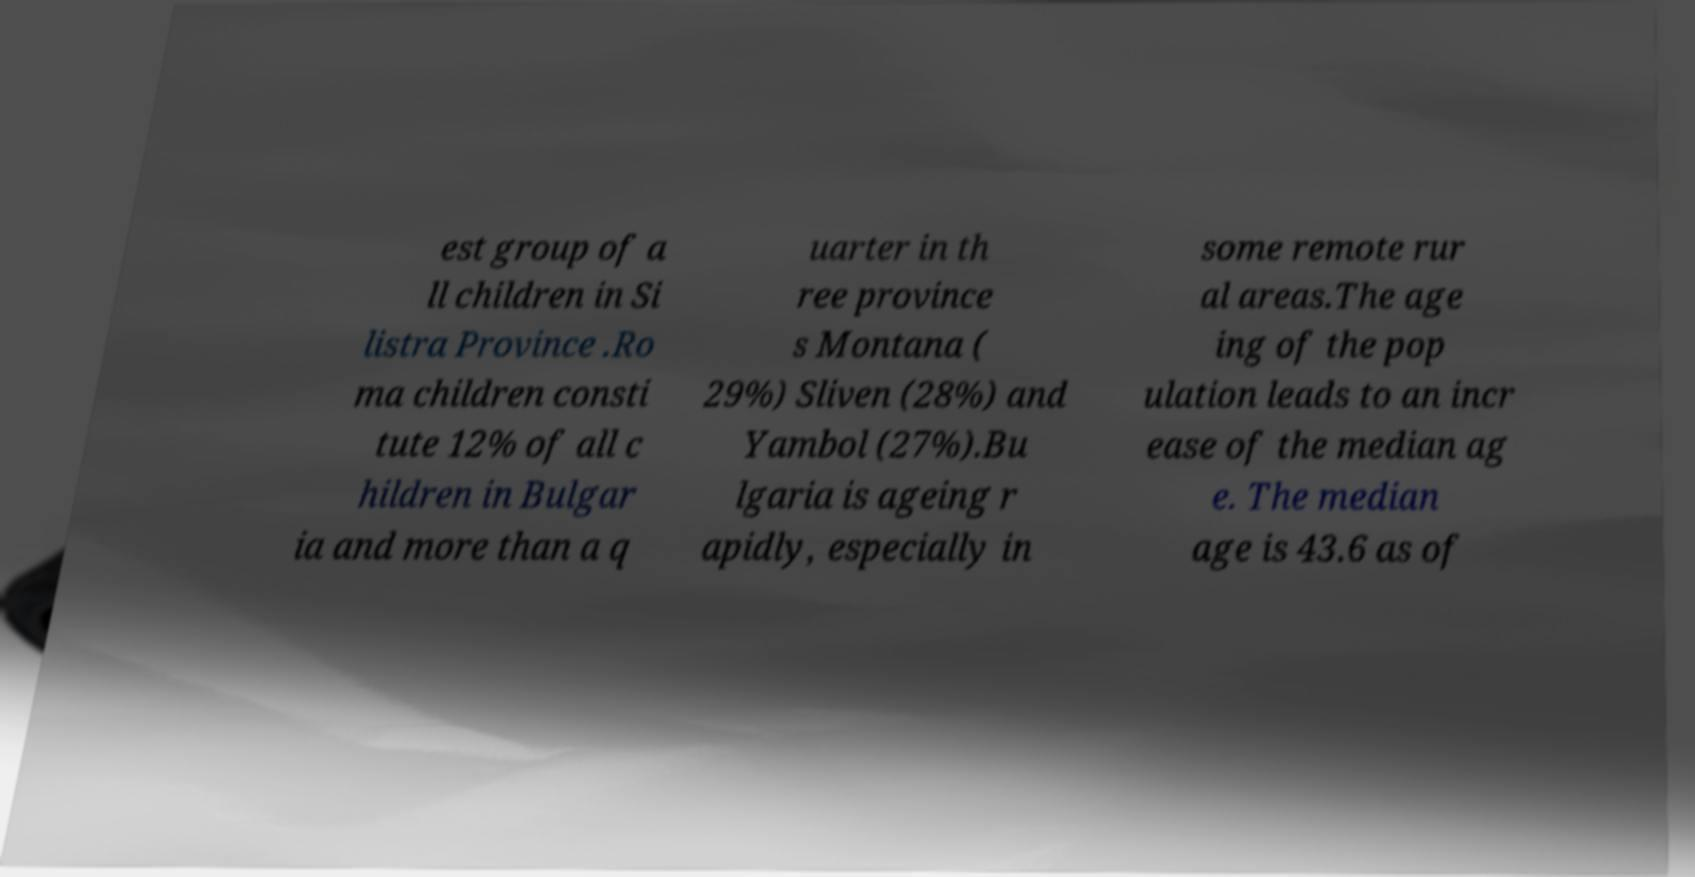Please read and relay the text visible in this image. What does it say? est group of a ll children in Si listra Province .Ro ma children consti tute 12% of all c hildren in Bulgar ia and more than a q uarter in th ree province s Montana ( 29%) Sliven (28%) and Yambol (27%).Bu lgaria is ageing r apidly, especially in some remote rur al areas.The age ing of the pop ulation leads to an incr ease of the median ag e. The median age is 43.6 as of 